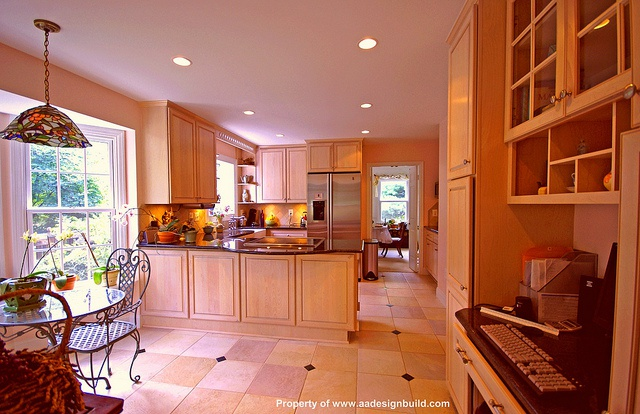Describe the objects in this image and their specific colors. I can see chair in gray, white, lightpink, darkgray, and pink tones, dining table in gray, ivory, maroon, and brown tones, refrigerator in gray, brown, and maroon tones, keyboard in gray, maroon, and brown tones, and potted plant in gray, maroon, white, black, and olive tones in this image. 